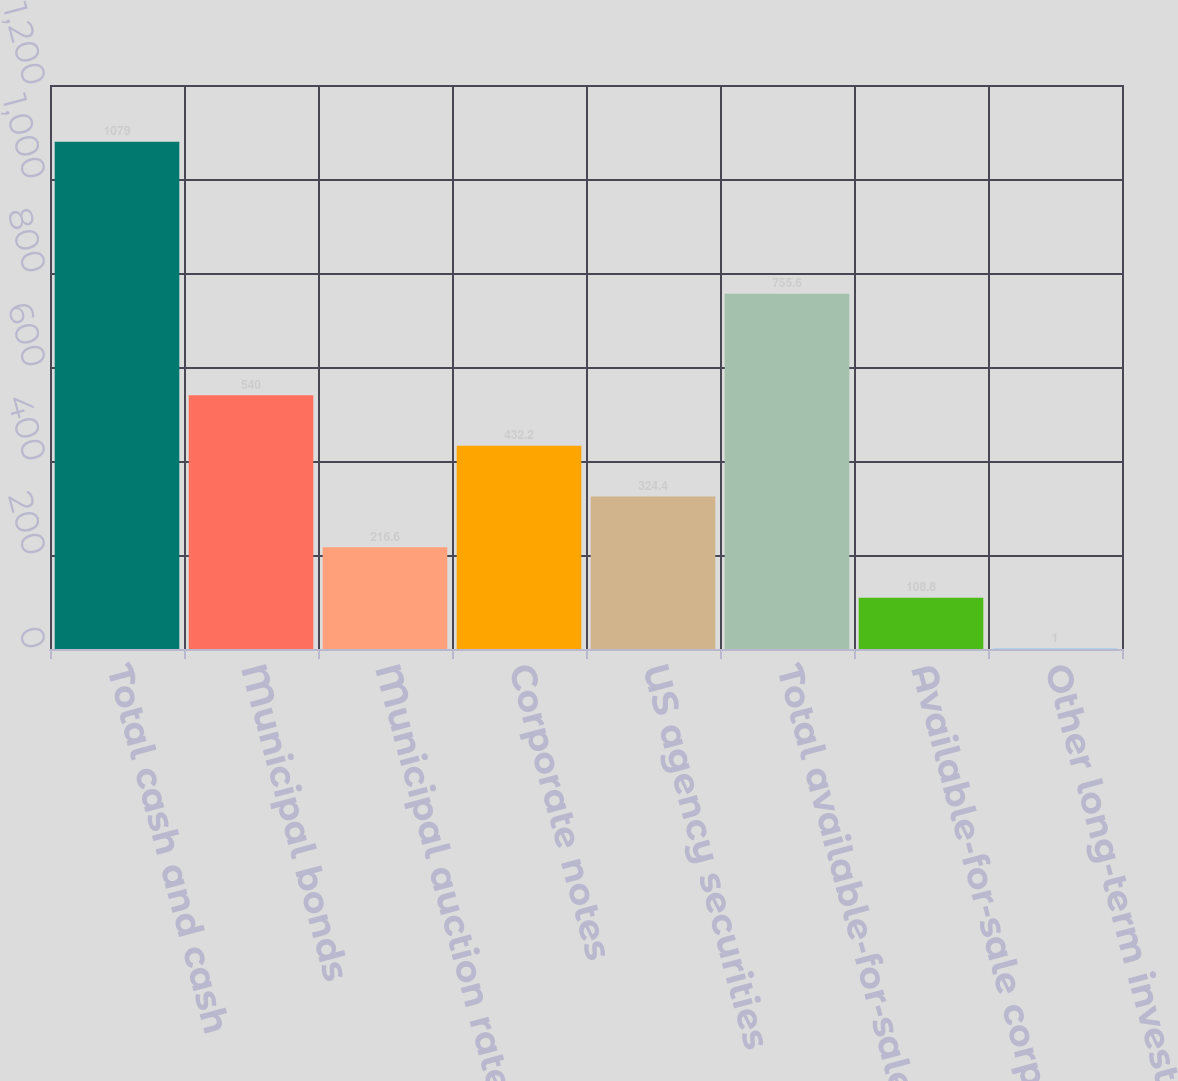Convert chart to OTSL. <chart><loc_0><loc_0><loc_500><loc_500><bar_chart><fcel>Total cash and cash<fcel>Municipal bonds<fcel>Municipal auction rate<fcel>Corporate notes<fcel>US agency securities<fcel>Total available-for-sale debt<fcel>Available-for-sale corporate<fcel>Other long-term investments<nl><fcel>1079<fcel>540<fcel>216.6<fcel>432.2<fcel>324.4<fcel>755.6<fcel>108.8<fcel>1<nl></chart> 